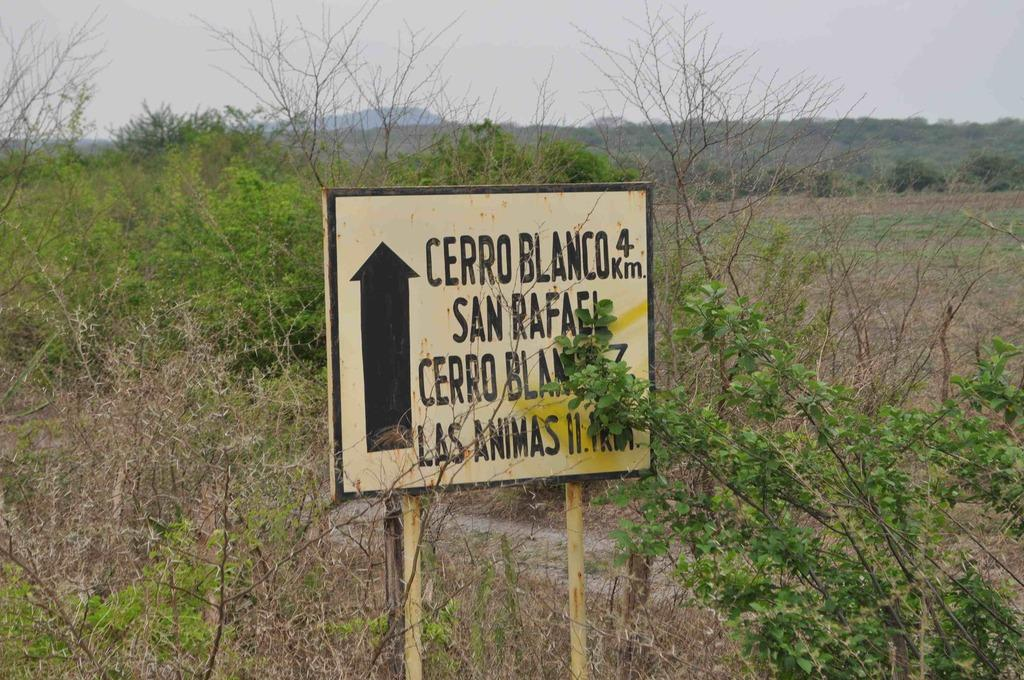Where was the image taken? The image is clicked outside. What type of natural elements can be seen in the image? There are plants and trees in the image. What is the main object in the middle of the image? There is a board in the middle of the image. What is visible at the top of the image? The sky is visible at the top of the image. Can you see any feet walking on the board in the image? There are no feet or people visible in the image, so it cannot be determined if anyone is walking on the board. Is there a lake visible in the image? There is no lake present in the image; it features plants, trees, a board, and the sky. 